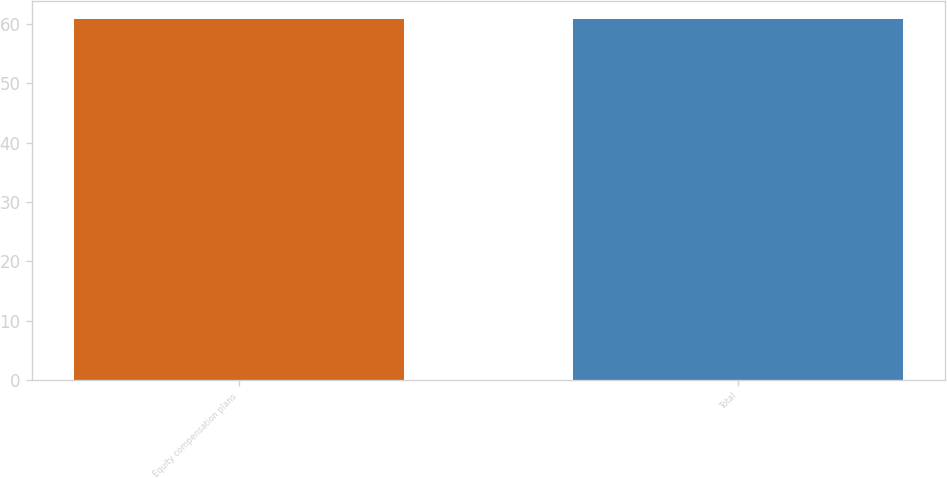<chart> <loc_0><loc_0><loc_500><loc_500><bar_chart><fcel>Equity compensation plans<fcel>Total<nl><fcel>60.78<fcel>60.88<nl></chart> 